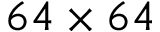<formula> <loc_0><loc_0><loc_500><loc_500>6 4 \times 6 4</formula> 